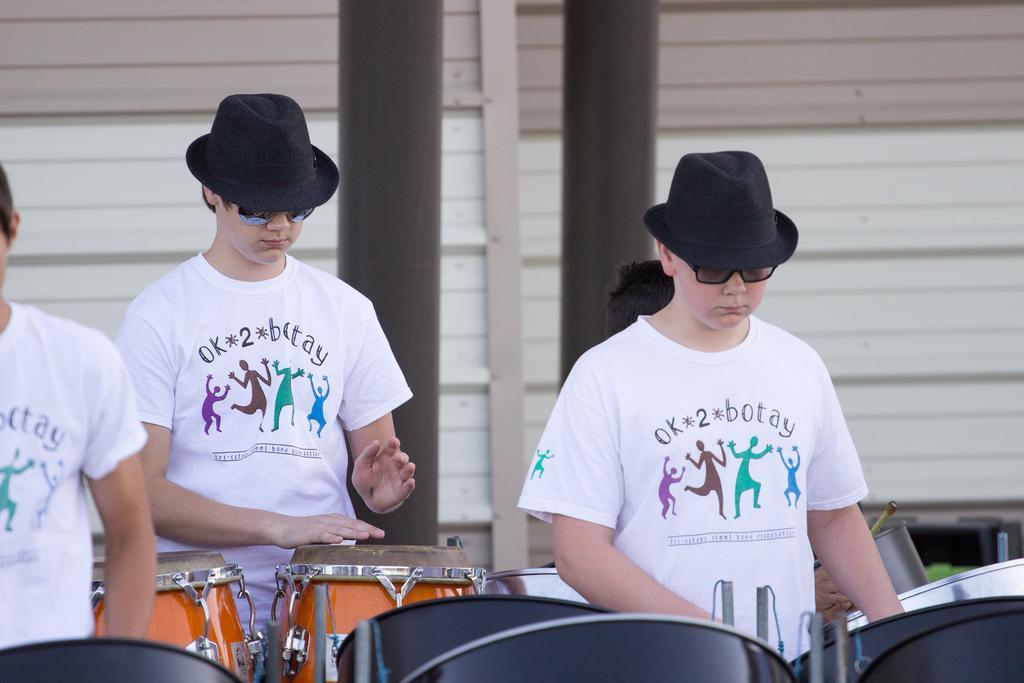In one or two sentences, can you explain what this image depicts? Here 3 people are standing and beating the drums and these two people are wearing white color shirts. 